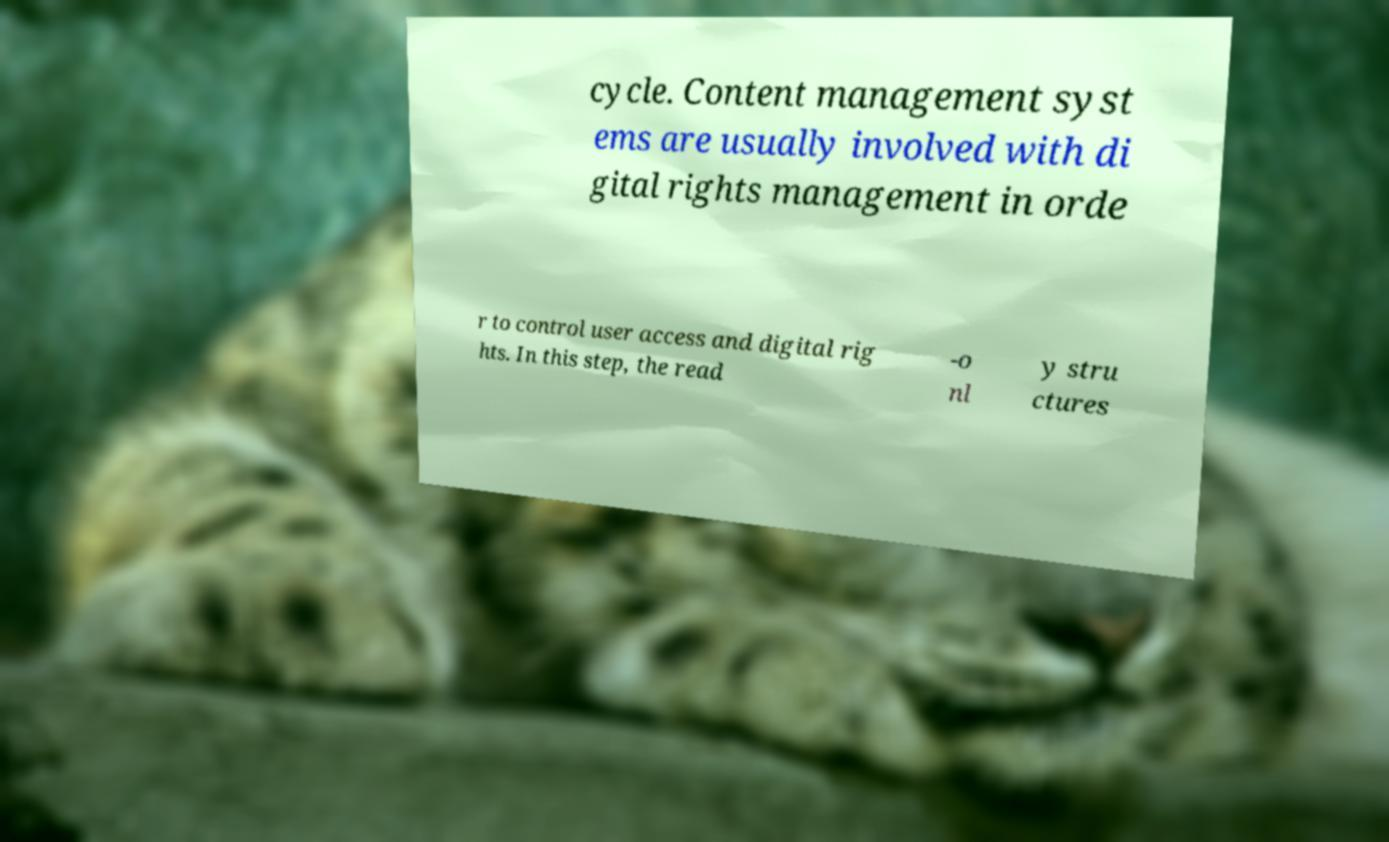Can you accurately transcribe the text from the provided image for me? cycle. Content management syst ems are usually involved with di gital rights management in orde r to control user access and digital rig hts. In this step, the read -o nl y stru ctures 